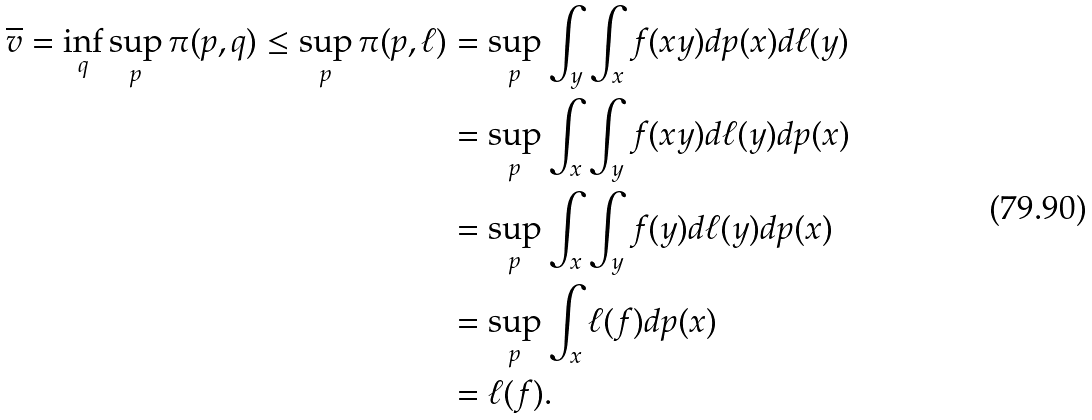<formula> <loc_0><loc_0><loc_500><loc_500>\overline { v } = \inf _ { q } \sup _ { p } \pi ( p , q ) \leq \sup _ { p } \pi ( p , \ell ) & = \sup _ { p } \int _ { y } \int _ { x } f ( x y ) d p ( x ) d \ell ( y ) \\ & = \sup _ { p } \int _ { x } \int _ { y } f ( x y ) d \ell ( y ) d p ( x ) \\ & = \sup _ { p } \int _ { x } \int _ { y } f ( y ) d \ell ( y ) d p ( x ) \\ & = \sup _ { p } \int _ { x } \ell ( f ) d p ( x ) \\ & = \ell ( f ) .</formula> 